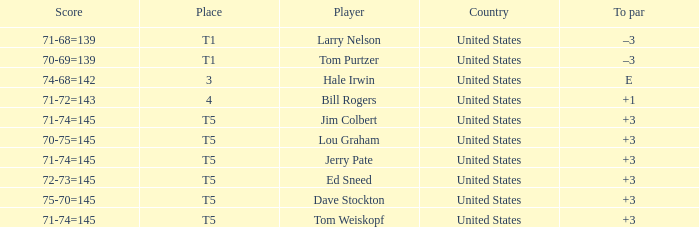What is the to par of player tom weiskopf, who has a 71-74=145 score? 3.0. 